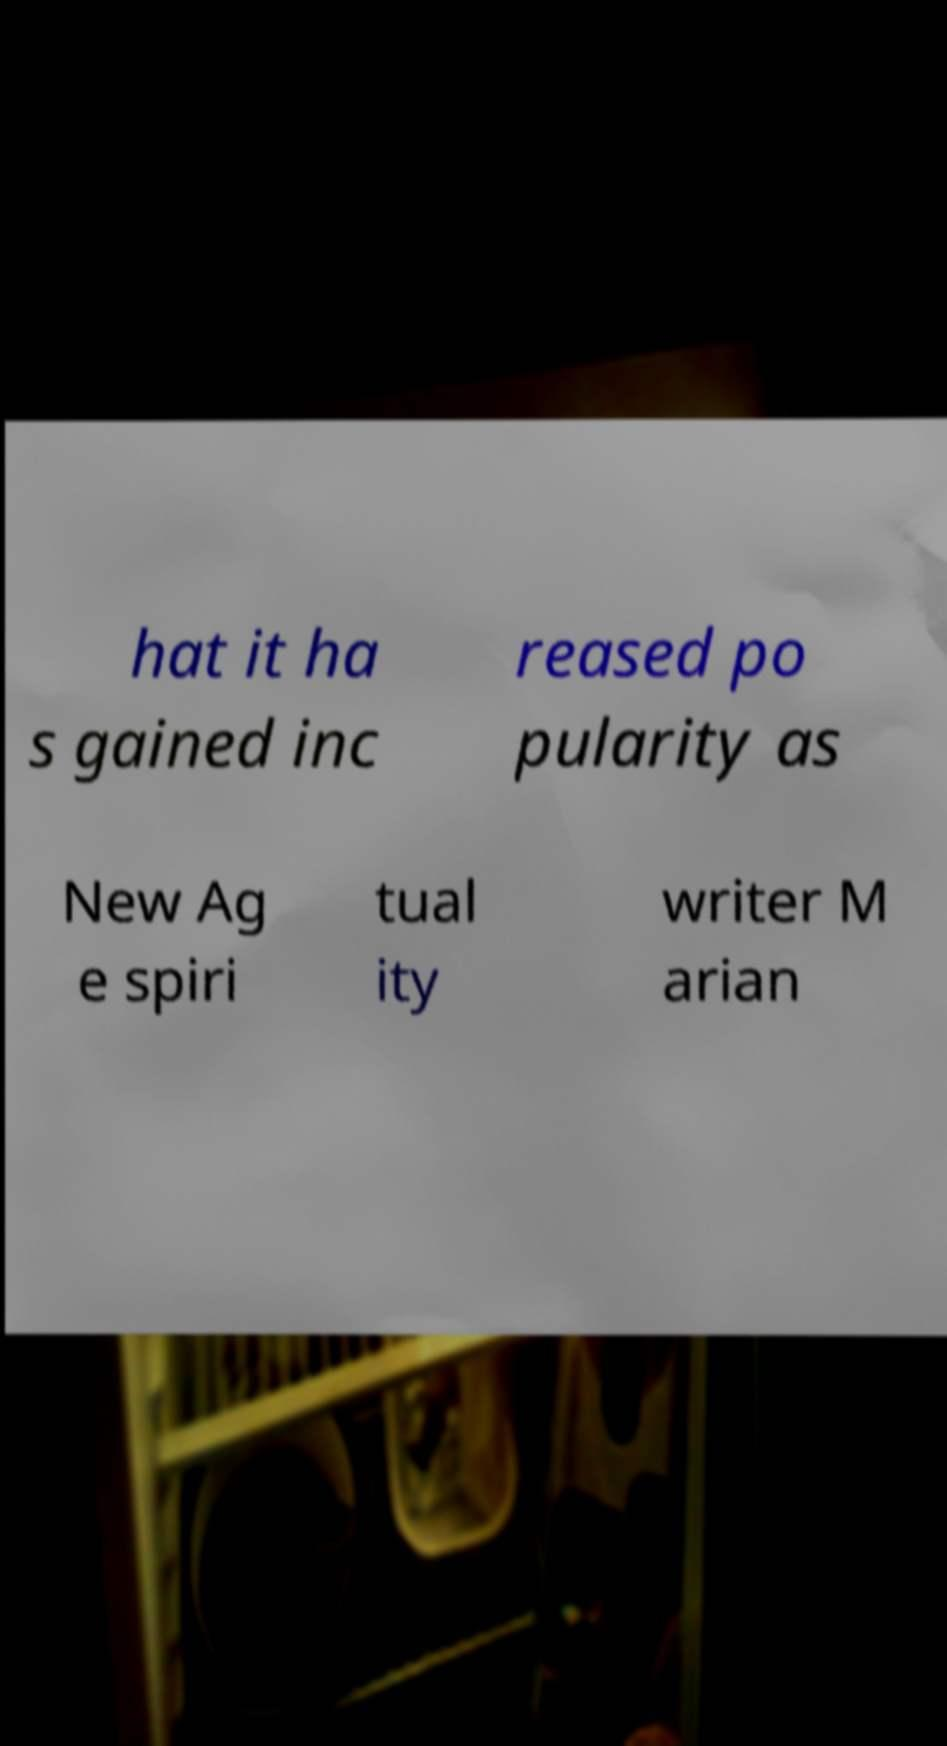Could you assist in decoding the text presented in this image and type it out clearly? hat it ha s gained inc reased po pularity as New Ag e spiri tual ity writer M arian 